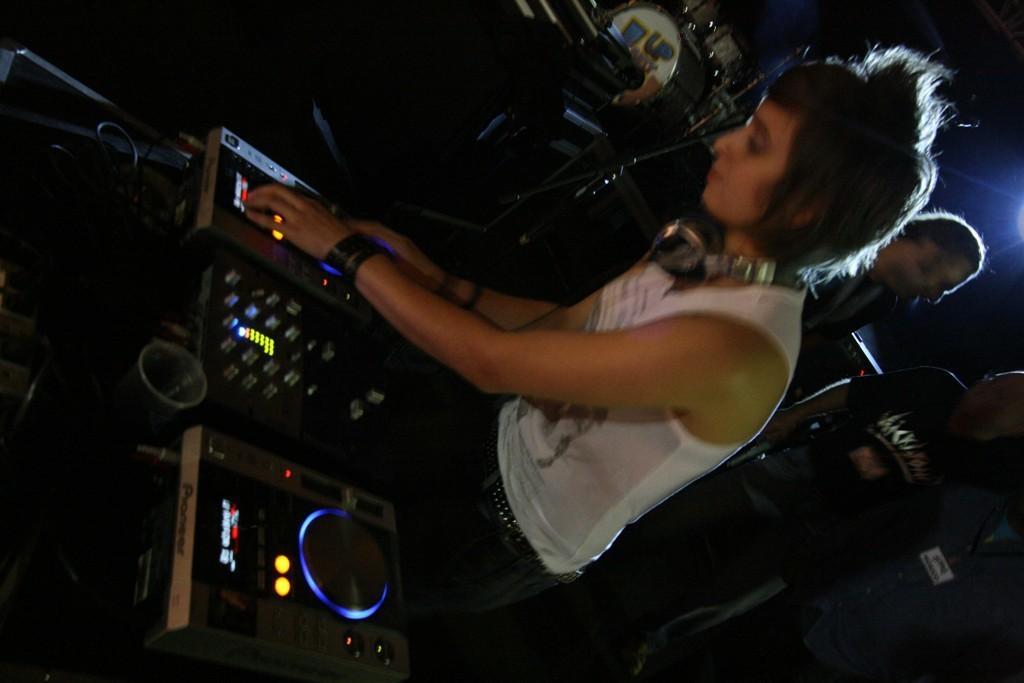Could you give a brief overview of what you see in this image? In this picture I can see a woman is controlling the disc jack, on the right side there are two men. 